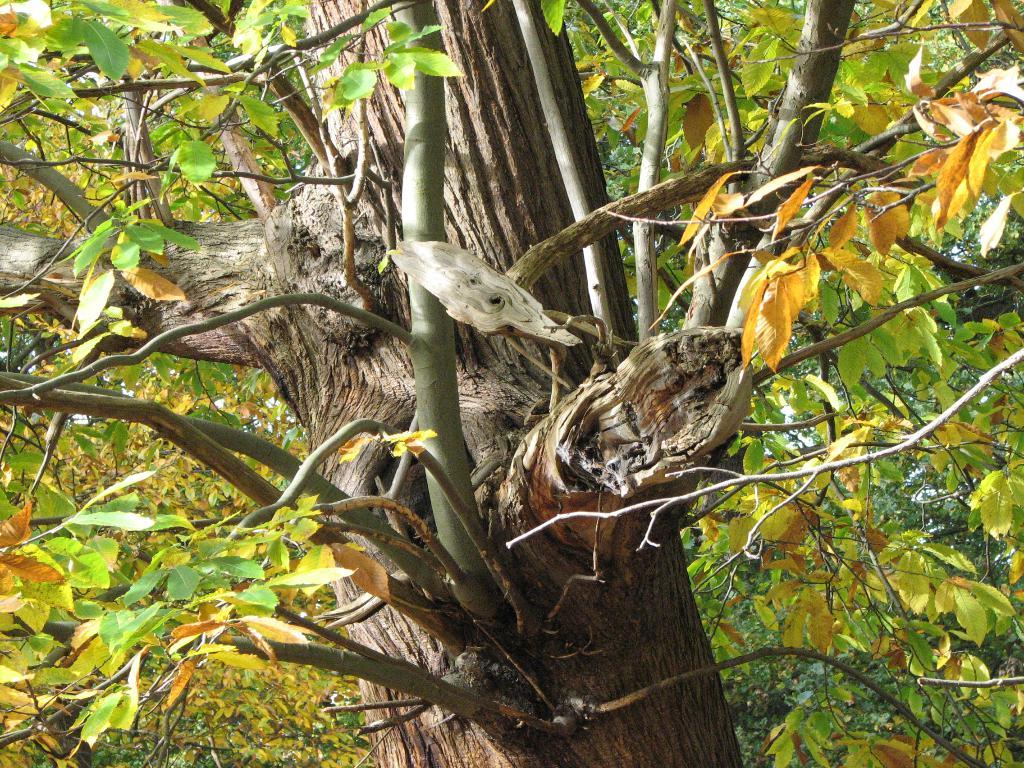What type of plant can be seen in the image? There is a tree in the image. What are the main features of the tree? The tree has branches and stems. What colors can be observed on the leaves of the tree? The leaves on the tree are green and orange in color. What type of comfort can be provided by the tree's voice in the image? There is no voice present in the image, as trees do not have the ability to speak or provide comfort. 